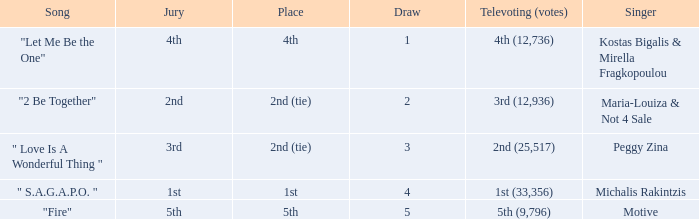Could you parse the entire table? {'header': ['Song', 'Jury', 'Place', 'Draw', 'Televoting (votes)', 'Singer'], 'rows': [['"Let Me Be the One"', '4th', '4th', '1', '4th (12,736)', 'Kostas Bigalis & Mirella Fragkopoulou'], ['"2 Be Together"', '2nd', '2nd (tie)', '2', '3rd (12,936)', 'Maria-Louiza & Not 4 Sale'], ['" Love Is A Wonderful Thing "', '3rd', '2nd (tie)', '3', '2nd (25,517)', 'Peggy Zina'], ['" S.A.G.A.P.O. "', '1st', '1st', '4', '1st (33,356)', 'Michalis Rakintzis'], ['"Fire"', '5th', '5th', '5', '5th (9,796)', 'Motive']]} The song "2 Be Together" had what jury? 2nd. 